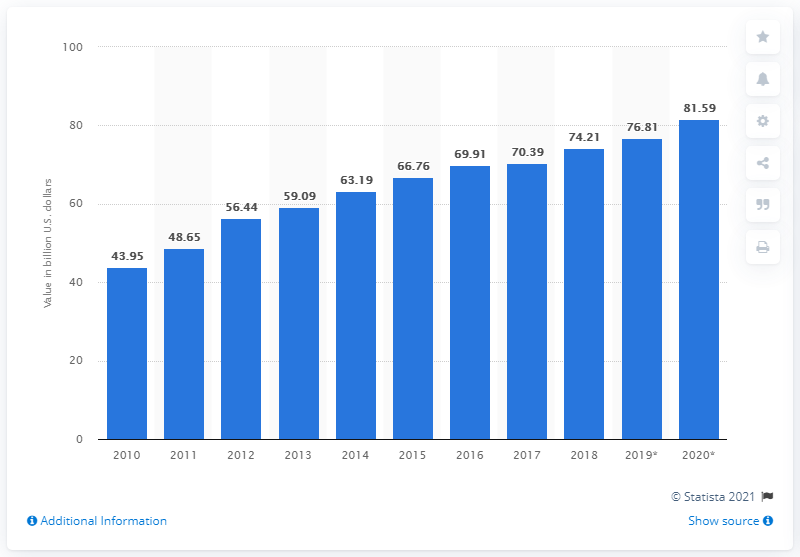List a handful of essential elements in this visual. Latin American and Caribbean countries are projected to pay approximately $81.59 million in debt interest by 2020. 